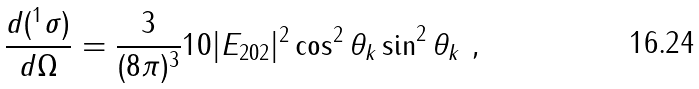Convert formula to latex. <formula><loc_0><loc_0><loc_500><loc_500>\frac { d ( ^ { 1 } \sigma ) } { d \Omega } = \frac { 3 } { ( 8 \pi ) ^ { 3 } } 1 0 | E _ { 2 0 2 } | ^ { 2 } \cos ^ { 2 } \theta _ { k } \sin ^ { 2 } \theta _ { k } \ ,</formula> 